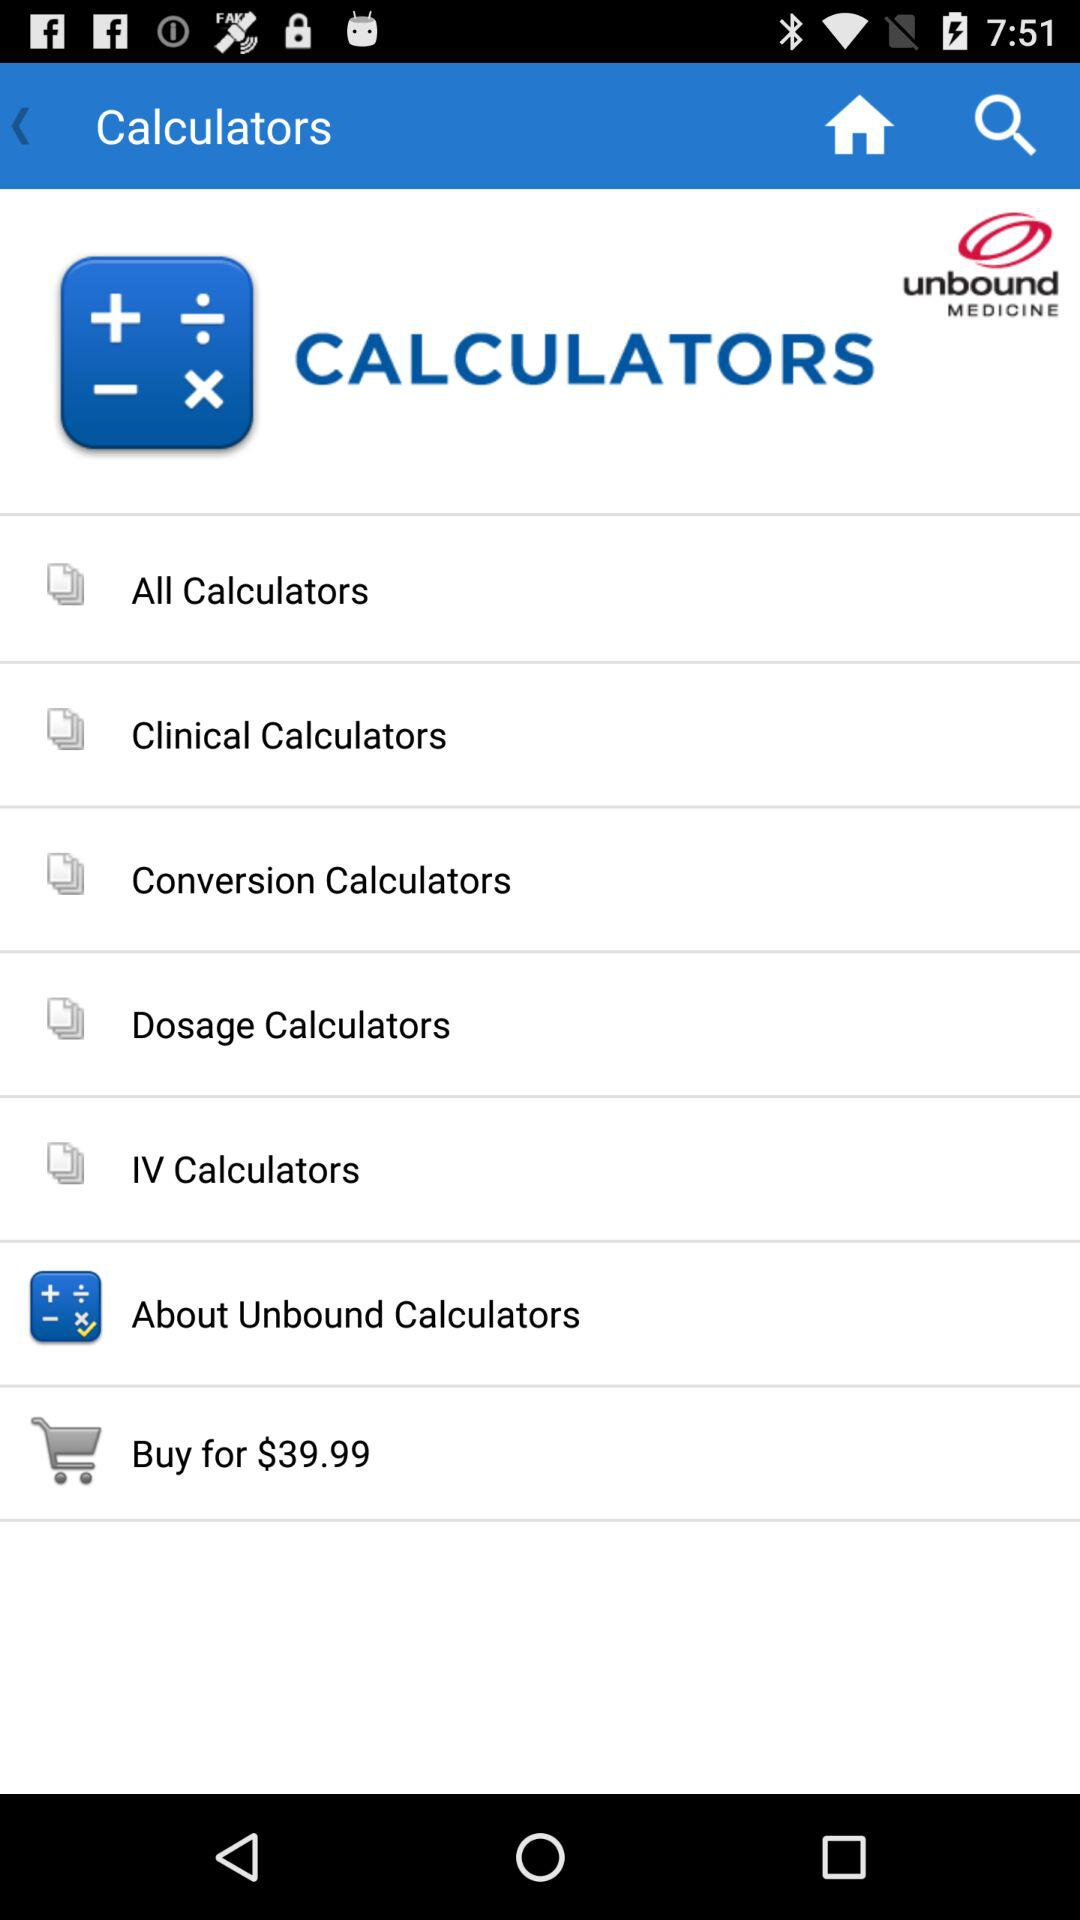Which option is selected? The selected option is "About Unbound Calculators". 